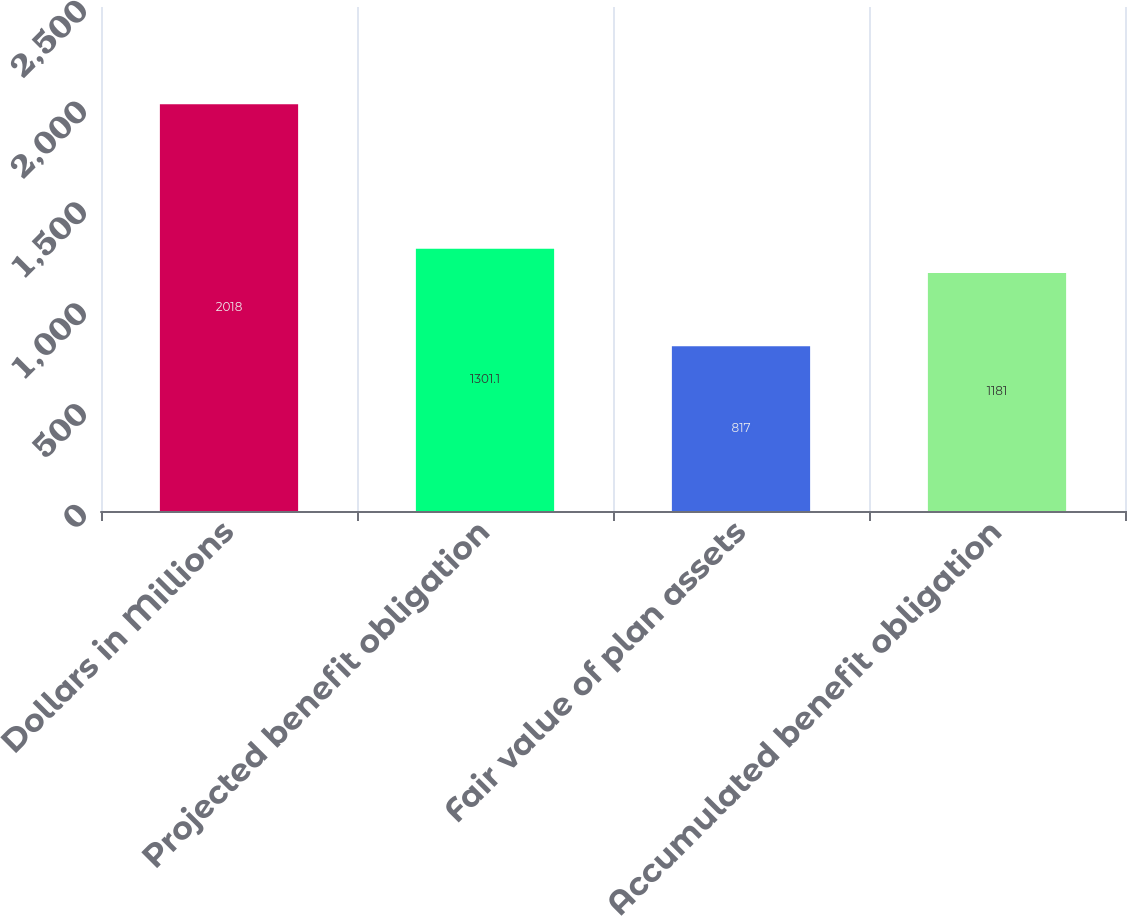<chart> <loc_0><loc_0><loc_500><loc_500><bar_chart><fcel>Dollars in Millions<fcel>Projected benefit obligation<fcel>Fair value of plan assets<fcel>Accumulated benefit obligation<nl><fcel>2018<fcel>1301.1<fcel>817<fcel>1181<nl></chart> 